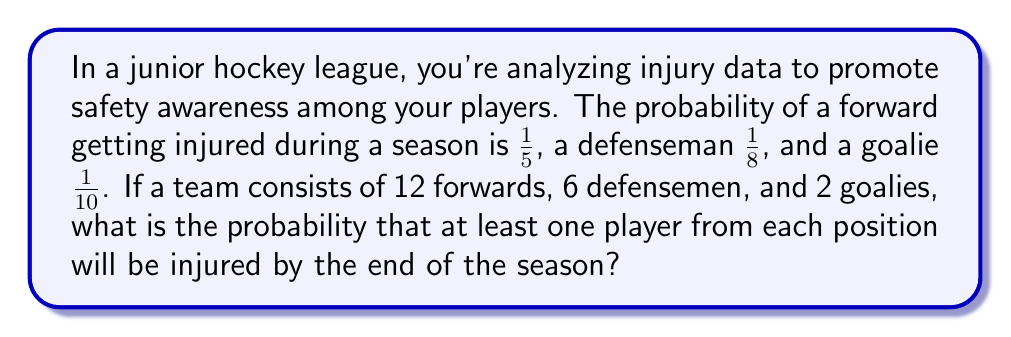Solve this math problem. Let's approach this step-by-step:

1) First, we need to find the probability that at least one player from each position is injured. It's easier to calculate the complement of this event (i.e., the probability that not all positions have at least one injured player).

2) Let's calculate the probability of no injuries for each position:
   - For forwards: $P(\text{no injured forwards}) = (1 - \frac{1}{5})^{12} = (\frac{4}{5})^{12}$
   - For defensemen: $P(\text{no injured defensemen}) = (1 - \frac{1}{8})^6 = (\frac{7}{8})^6$
   - For goalies: $P(\text{no injured goalies}) = (1 - \frac{1}{10})^2 = (\frac{9}{10})^2$

3) The probability that at least one position has no injuries is:
   $$1 - [(1 - (\frac{4}{5})^{12}) \times (1 - (\frac{7}{8})^6) \times (1 - (\frac{9}{10})^2)]$$

4) Let's calculate each part:
   - $(\frac{4}{5})^{12} \approx 0.0687$
   - $(\frac{7}{8})^6 \approx 0.4487$
   - $(\frac{9}{10})^2 = 0.81$

5) Now, we can plug these values into our equation:
   $$1 - [(1 - 0.0687) \times (1 - 0.4487) \times (1 - 0.81)]$$
   $$= 1 - [0.9313 \times 0.5513 \times 0.19]$$
   $$= 1 - 0.0975$$
   $$= 0.9025$$

6) Therefore, the probability that at least one player from each position will be injured is approximately 0.9025 or 90.25%.
Answer: $0.9025$ or $90.25\%$ 